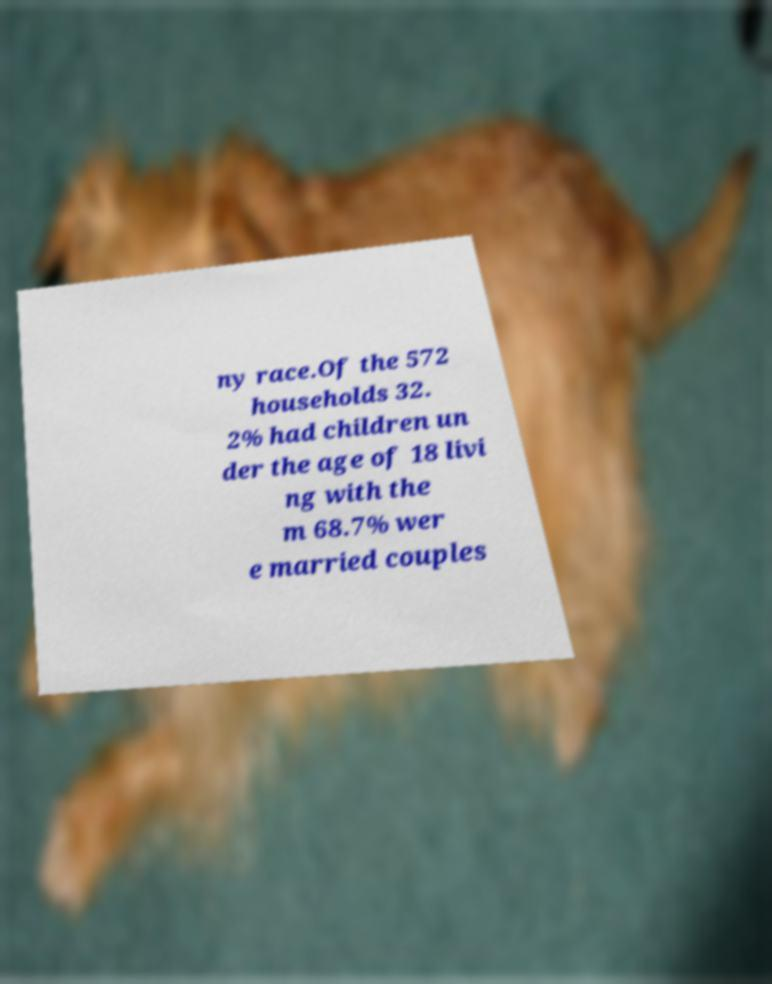Could you assist in decoding the text presented in this image and type it out clearly? ny race.Of the 572 households 32. 2% had children un der the age of 18 livi ng with the m 68.7% wer e married couples 